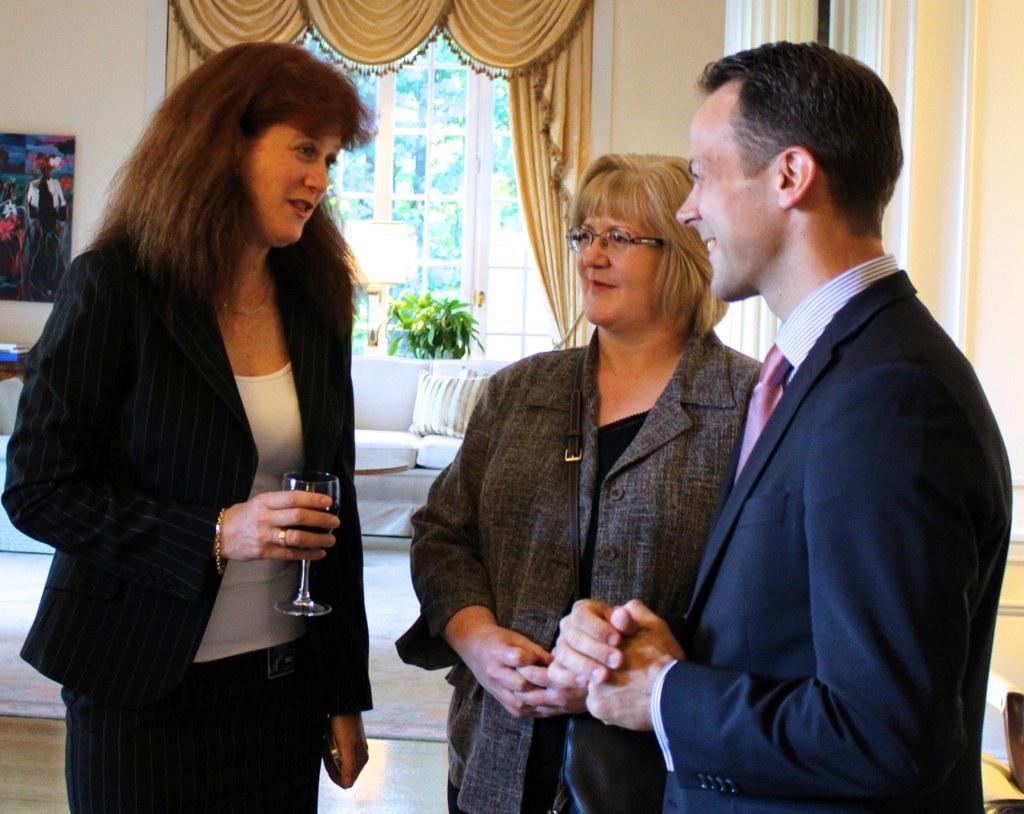Please provide a concise description of this image. In this image there is a man and two women standing. One of the woman is holding a mobile phone and also a glass of drink. In the background there is a window, a sofa with a cushion, a frame to the plain wall and also curtains visible in this image. Plant is also present. 